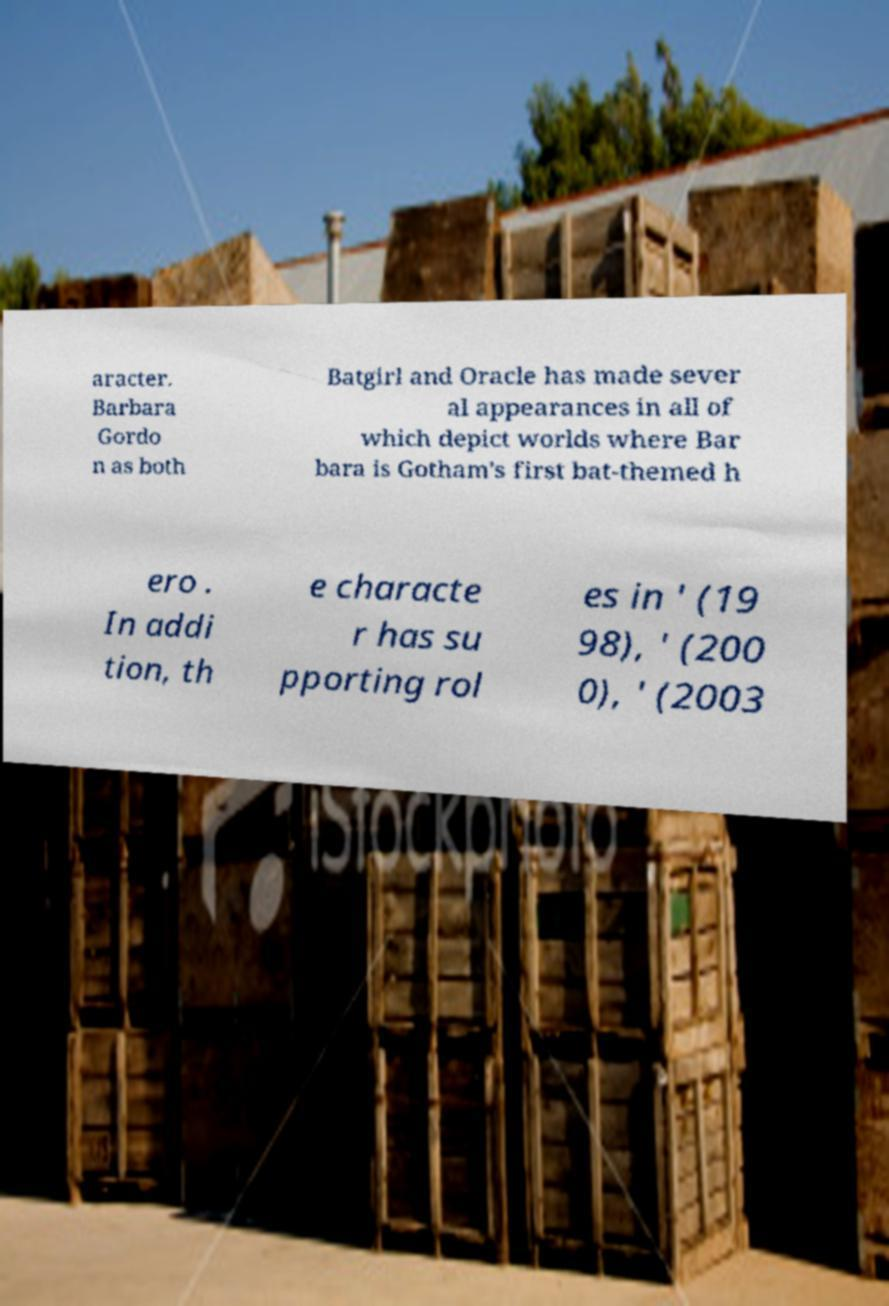Can you accurately transcribe the text from the provided image for me? aracter. Barbara Gordo n as both Batgirl and Oracle has made sever al appearances in all of which depict worlds where Bar bara is Gotham's first bat-themed h ero . In addi tion, th e characte r has su pporting rol es in ' (19 98), ' (200 0), ' (2003 